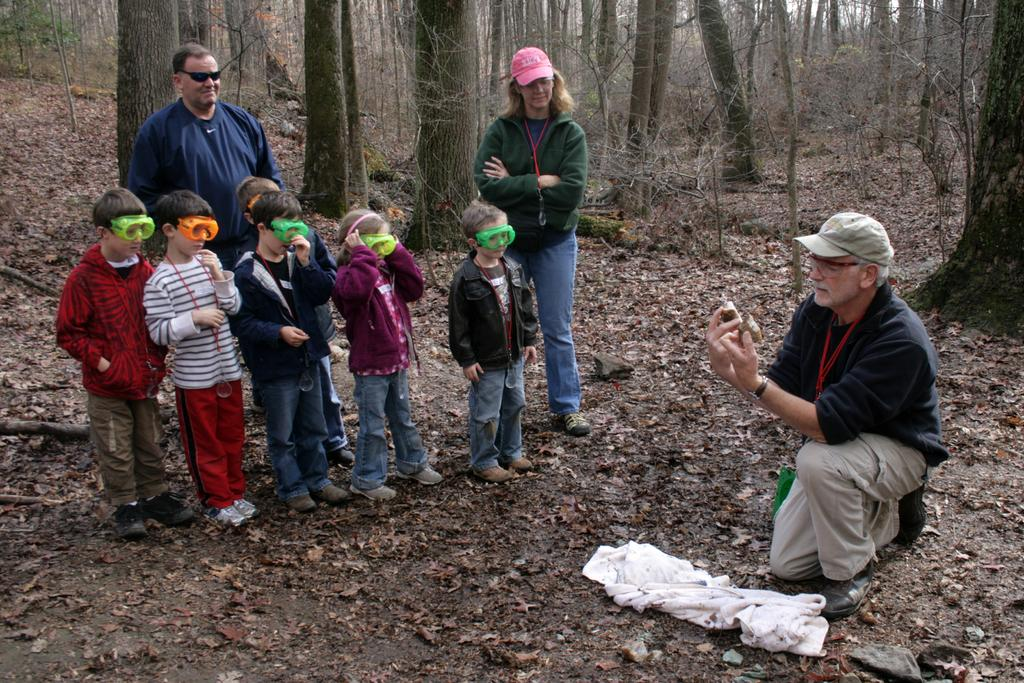What is happening with the people in the image? There are people standing on a land in the image. Can you describe the position of one of the individuals? There is a man laying on his knees in the image. What can be seen in the background of the image? There are trees in the background of the image. What type of string is being used by the daughter in the image? There is no daughter present in the image, and therefore no string being used. 